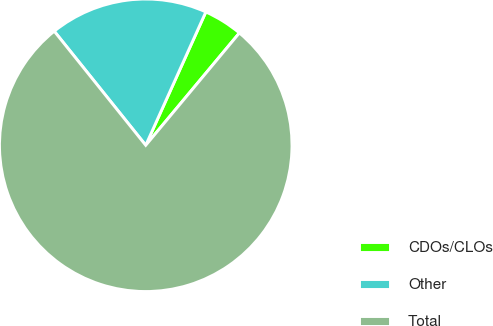Convert chart. <chart><loc_0><loc_0><loc_500><loc_500><pie_chart><fcel>CDOs/CLOs<fcel>Other<fcel>Total<nl><fcel>4.32%<fcel>17.5%<fcel>78.18%<nl></chart> 